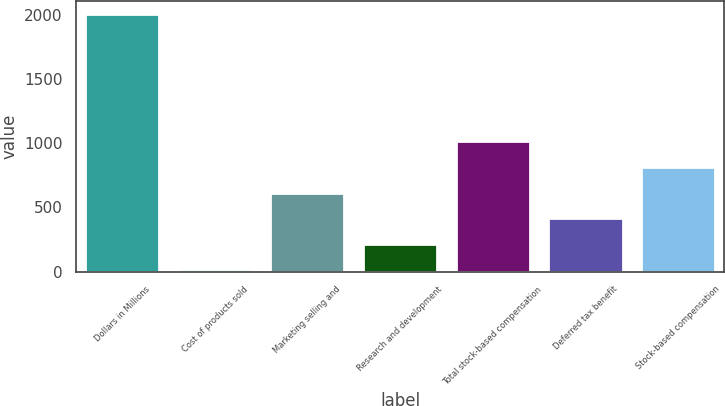Convert chart. <chart><loc_0><loc_0><loc_500><loc_500><bar_chart><fcel>Dollars in Millions<fcel>Cost of products sold<fcel>Marketing selling and<fcel>Research and development<fcel>Total stock-based compensation<fcel>Deferred tax benefit<fcel>Stock-based compensation<nl><fcel>2008<fcel>18<fcel>615<fcel>217<fcel>1013<fcel>416<fcel>814<nl></chart> 